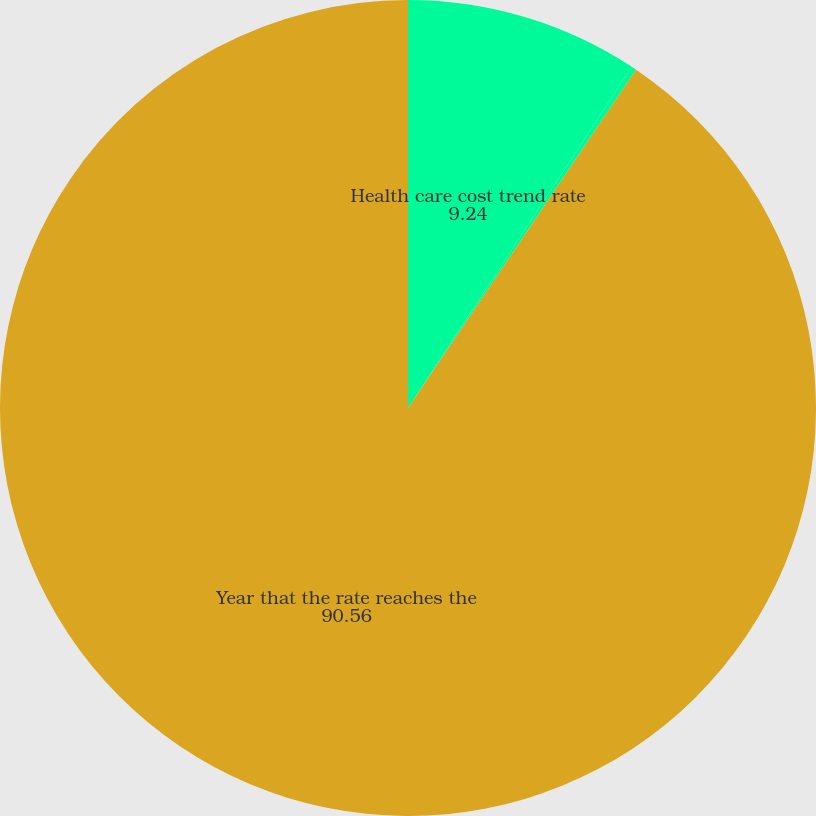Convert chart to OTSL. <chart><loc_0><loc_0><loc_500><loc_500><pie_chart><fcel>Health care cost trend rate<fcel>Rate to which the cost trend<fcel>Year that the rate reaches the<nl><fcel>9.24%<fcel>0.2%<fcel>90.56%<nl></chart> 